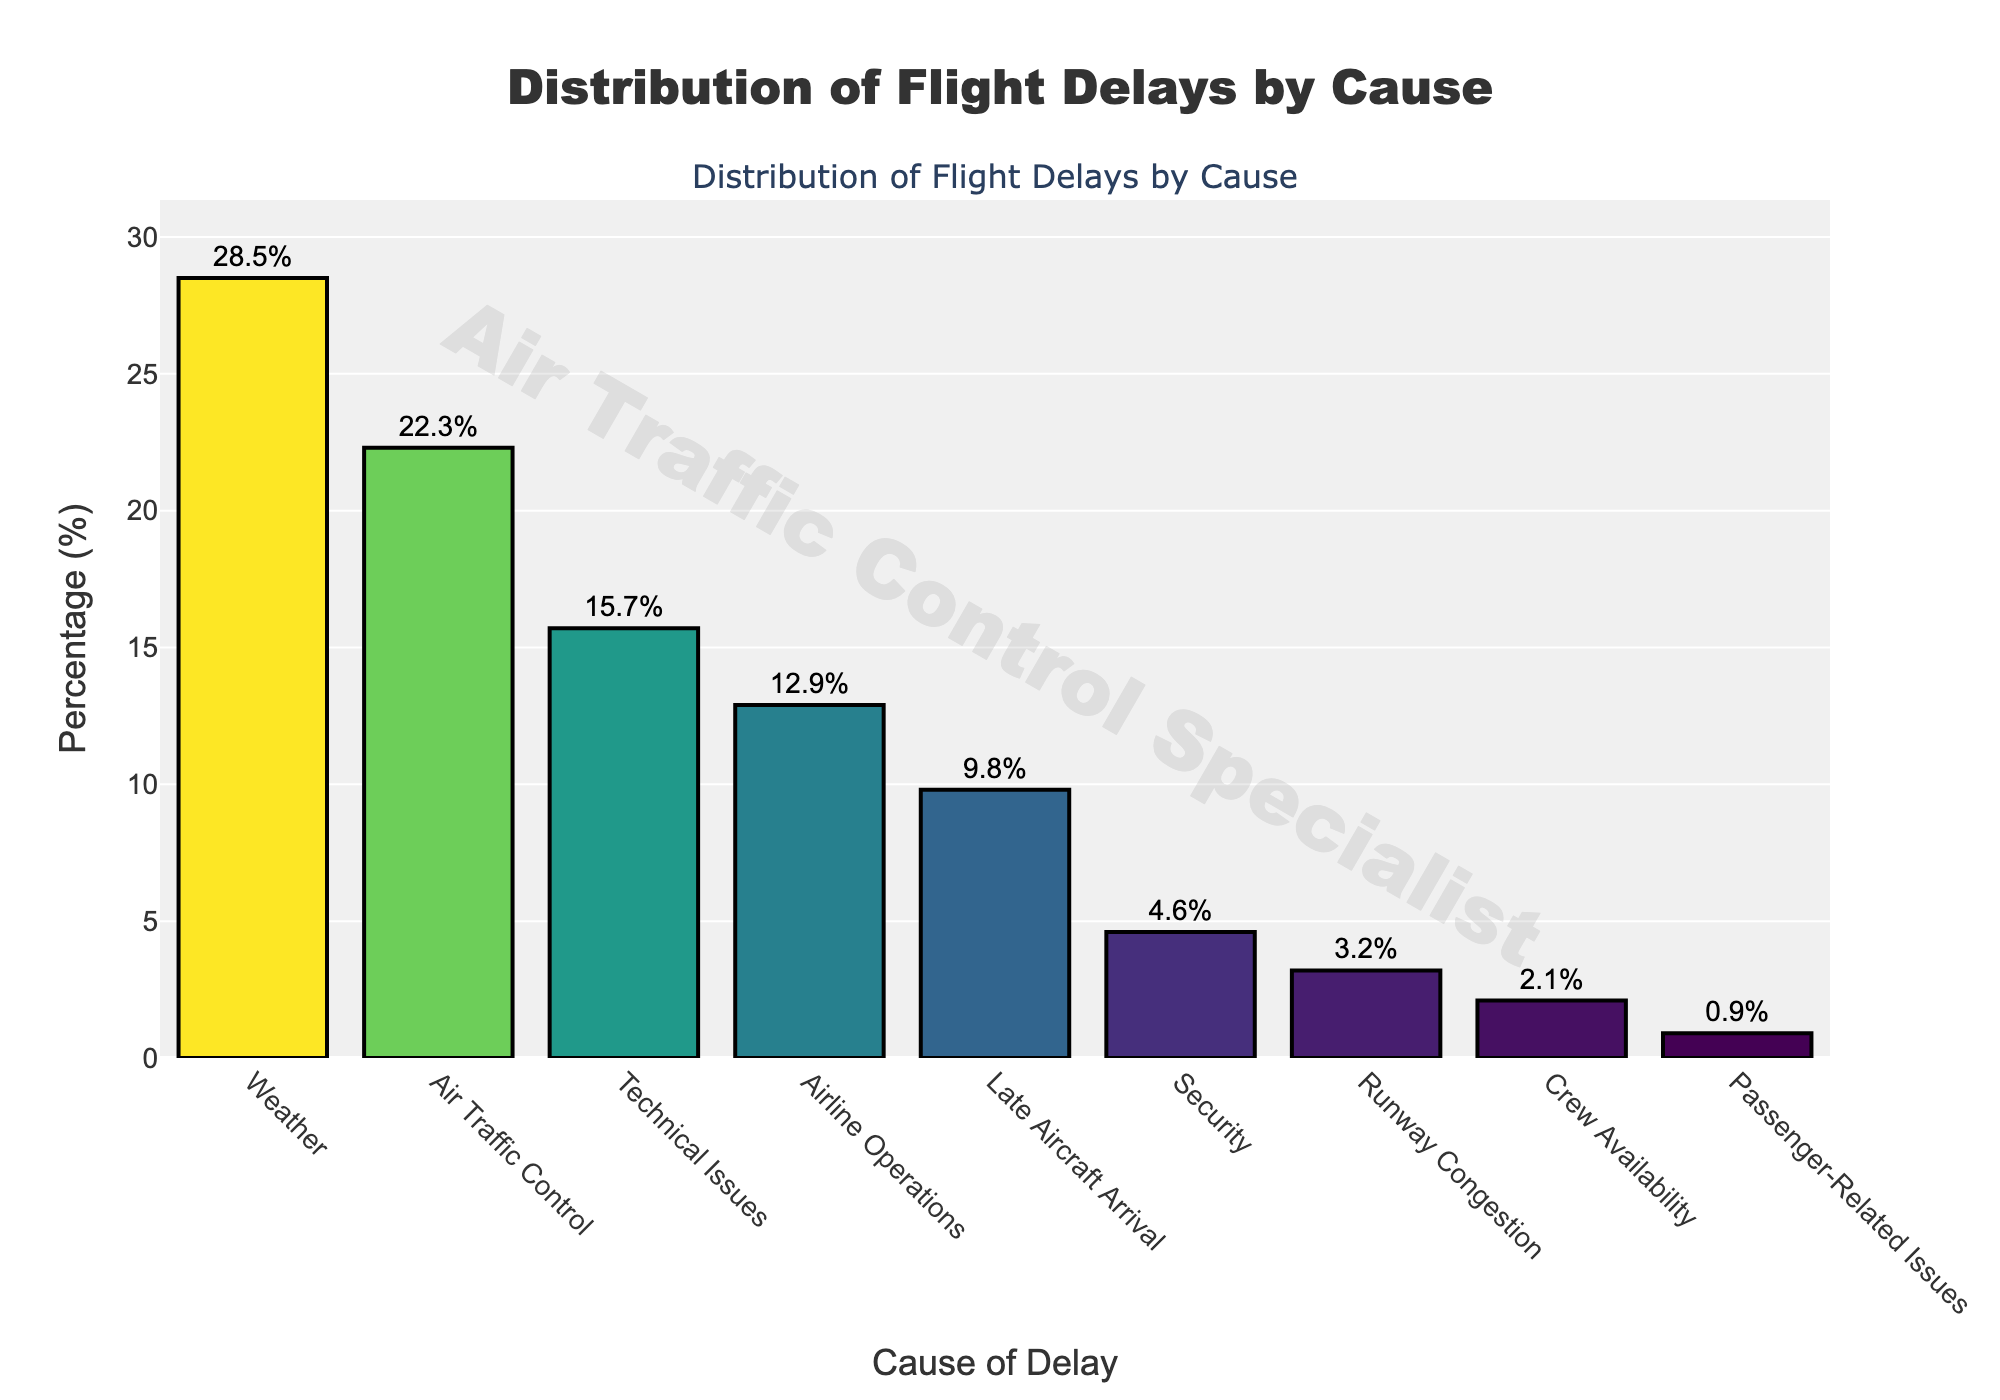What percentage of flight delays is caused by weather? The bar representing 'Weather' shows a percentage of 28.5%.
Answer: 28.5% Which cause has the second highest percentage of flight delays? The bar representing 'Air Traffic Control' is the second tallest bar with a percentage of 22.3%.
Answer: Air Traffic Control Is the percentage of delays due to Technical Issues greater than the percentage for Airline Operations? The bar for 'Technical Issues' is taller than the bar for 'Airline Operations', with percentages of 15.7% and 12.9% respectively.
Answer: Yes What is the combined percentage of flight delays caused by Weather and Air Traffic Control? Add the percentages for 'Weather' (28.5%) and 'Air Traffic Control' (22.3%). 28.5% + 22.3% = 50.8%
Answer: 50.8% Which cause has the lowest percentage of flight delays? The shortest bar represents 'Passenger-Related Issues' with a percentage of 0.9%.
Answer: Passenger-Related Issues Is the percentage of delays caused by Security more than double the percentage caused by Crew Availability? The percentage for 'Security' is 4.6% and for 'Crew Availability' is 2.1%. Since 4.6% is more than twice 2.1%, the answer is yes.
Answer: Yes Rank the top three causes of flight delays by percentage. The three tallest bars are for 'Weather' (28.5%), 'Air Traffic Control' (22.3%), and 'Technical Issues' (15.7%).
Answer: Weather, Air Traffic Control, Technical Issues What is the percentage difference between delays caused by Late Aircraft Arrival and Security? Subtract the percentage of 'Security' (4.6%) from 'Late Aircraft Arrival' (9.8%). 9.8% - 4.6% = 5.2%
Answer: 5.2% Is the total percentage of delays caused by Airline Operations, Security, and Late Aircraft Arrival less than 30%? Add the percentages for 'Airline Operations' (12.9%), 'Security' (4.6%), and 'Late Aircraft Arrival' (9.8%). 12.9% + 4.6% + 9.8% = 27.3%, which is less than 30%.
Answer: Yes What is the percentage for runway congestion and how does it visually compare to technical issues? The percentage for 'Runway Congestion' is 3.2%, which is considerably lower than 'Technical Issues' at 15.7%. This is visually apparent as the bar for 'Runway Congestion' is much shorter.
Answer: 3.2%, significantly shorter 